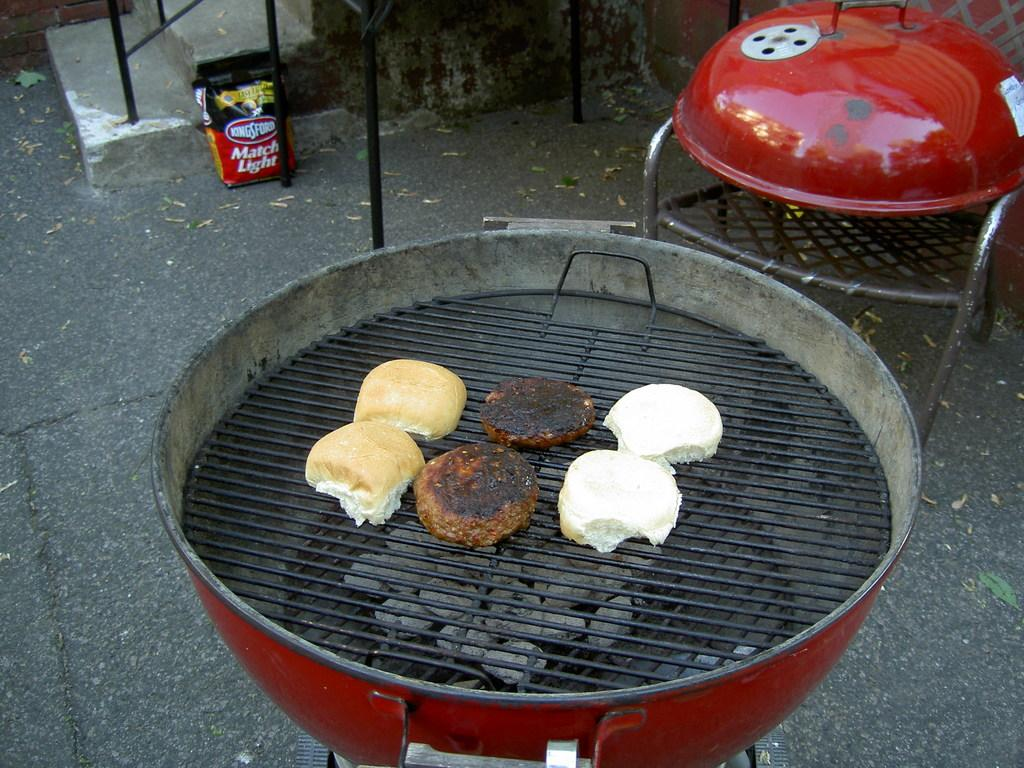<image>
Offer a succinct explanation of the picture presented. burgers and buns are grilling on a charcoal grill with kingsford charcoal 